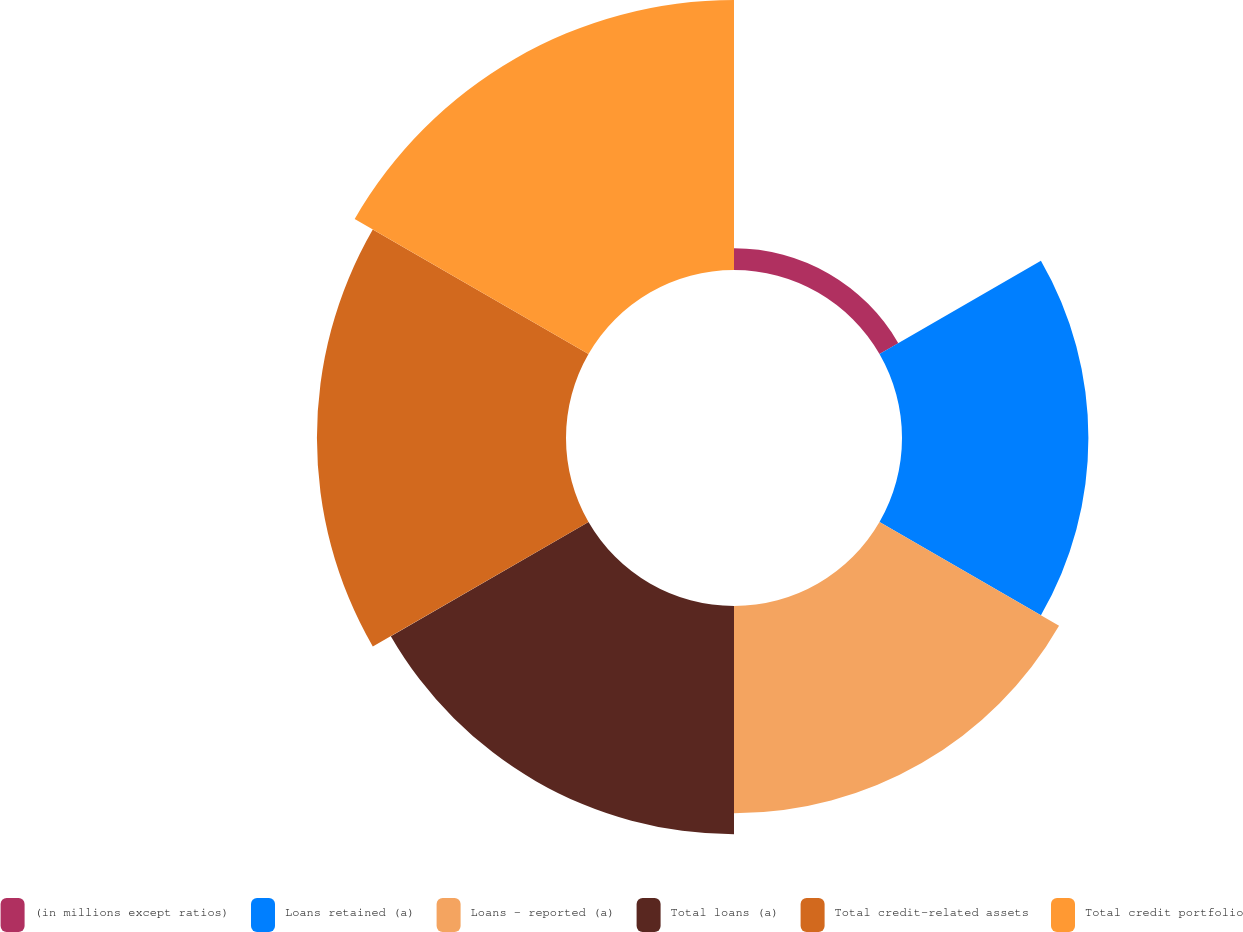<chart> <loc_0><loc_0><loc_500><loc_500><pie_chart><fcel>(in millions except ratios)<fcel>Loans retained (a)<fcel>Loans - reported (a)<fcel>Total loans (a)<fcel>Total credit-related assets<fcel>Total credit portfolio<nl><fcel>1.87%<fcel>16.03%<fcel>17.83%<fcel>19.63%<fcel>21.42%<fcel>23.22%<nl></chart> 